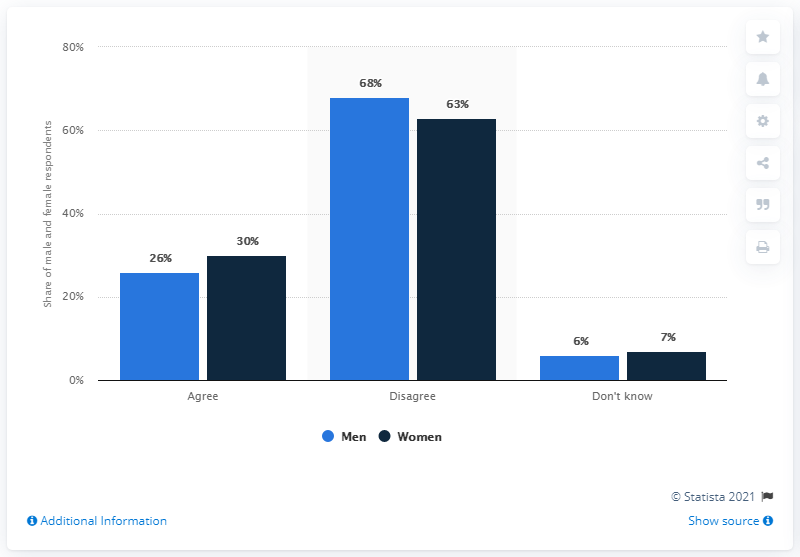Specify some key components in this picture. According to a survey, 26% of British men agreed that their financial situation was causing stress for them and their family. 